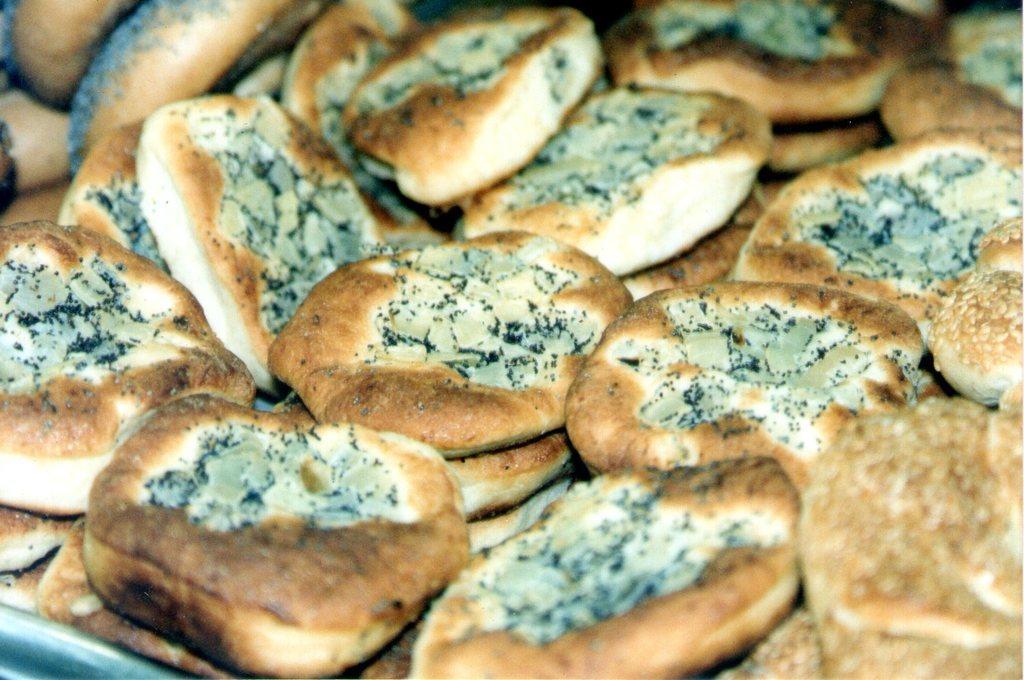In one or two sentences, can you explain what this image depicts? In this image we can see some bread which are in brown, black and white color. 